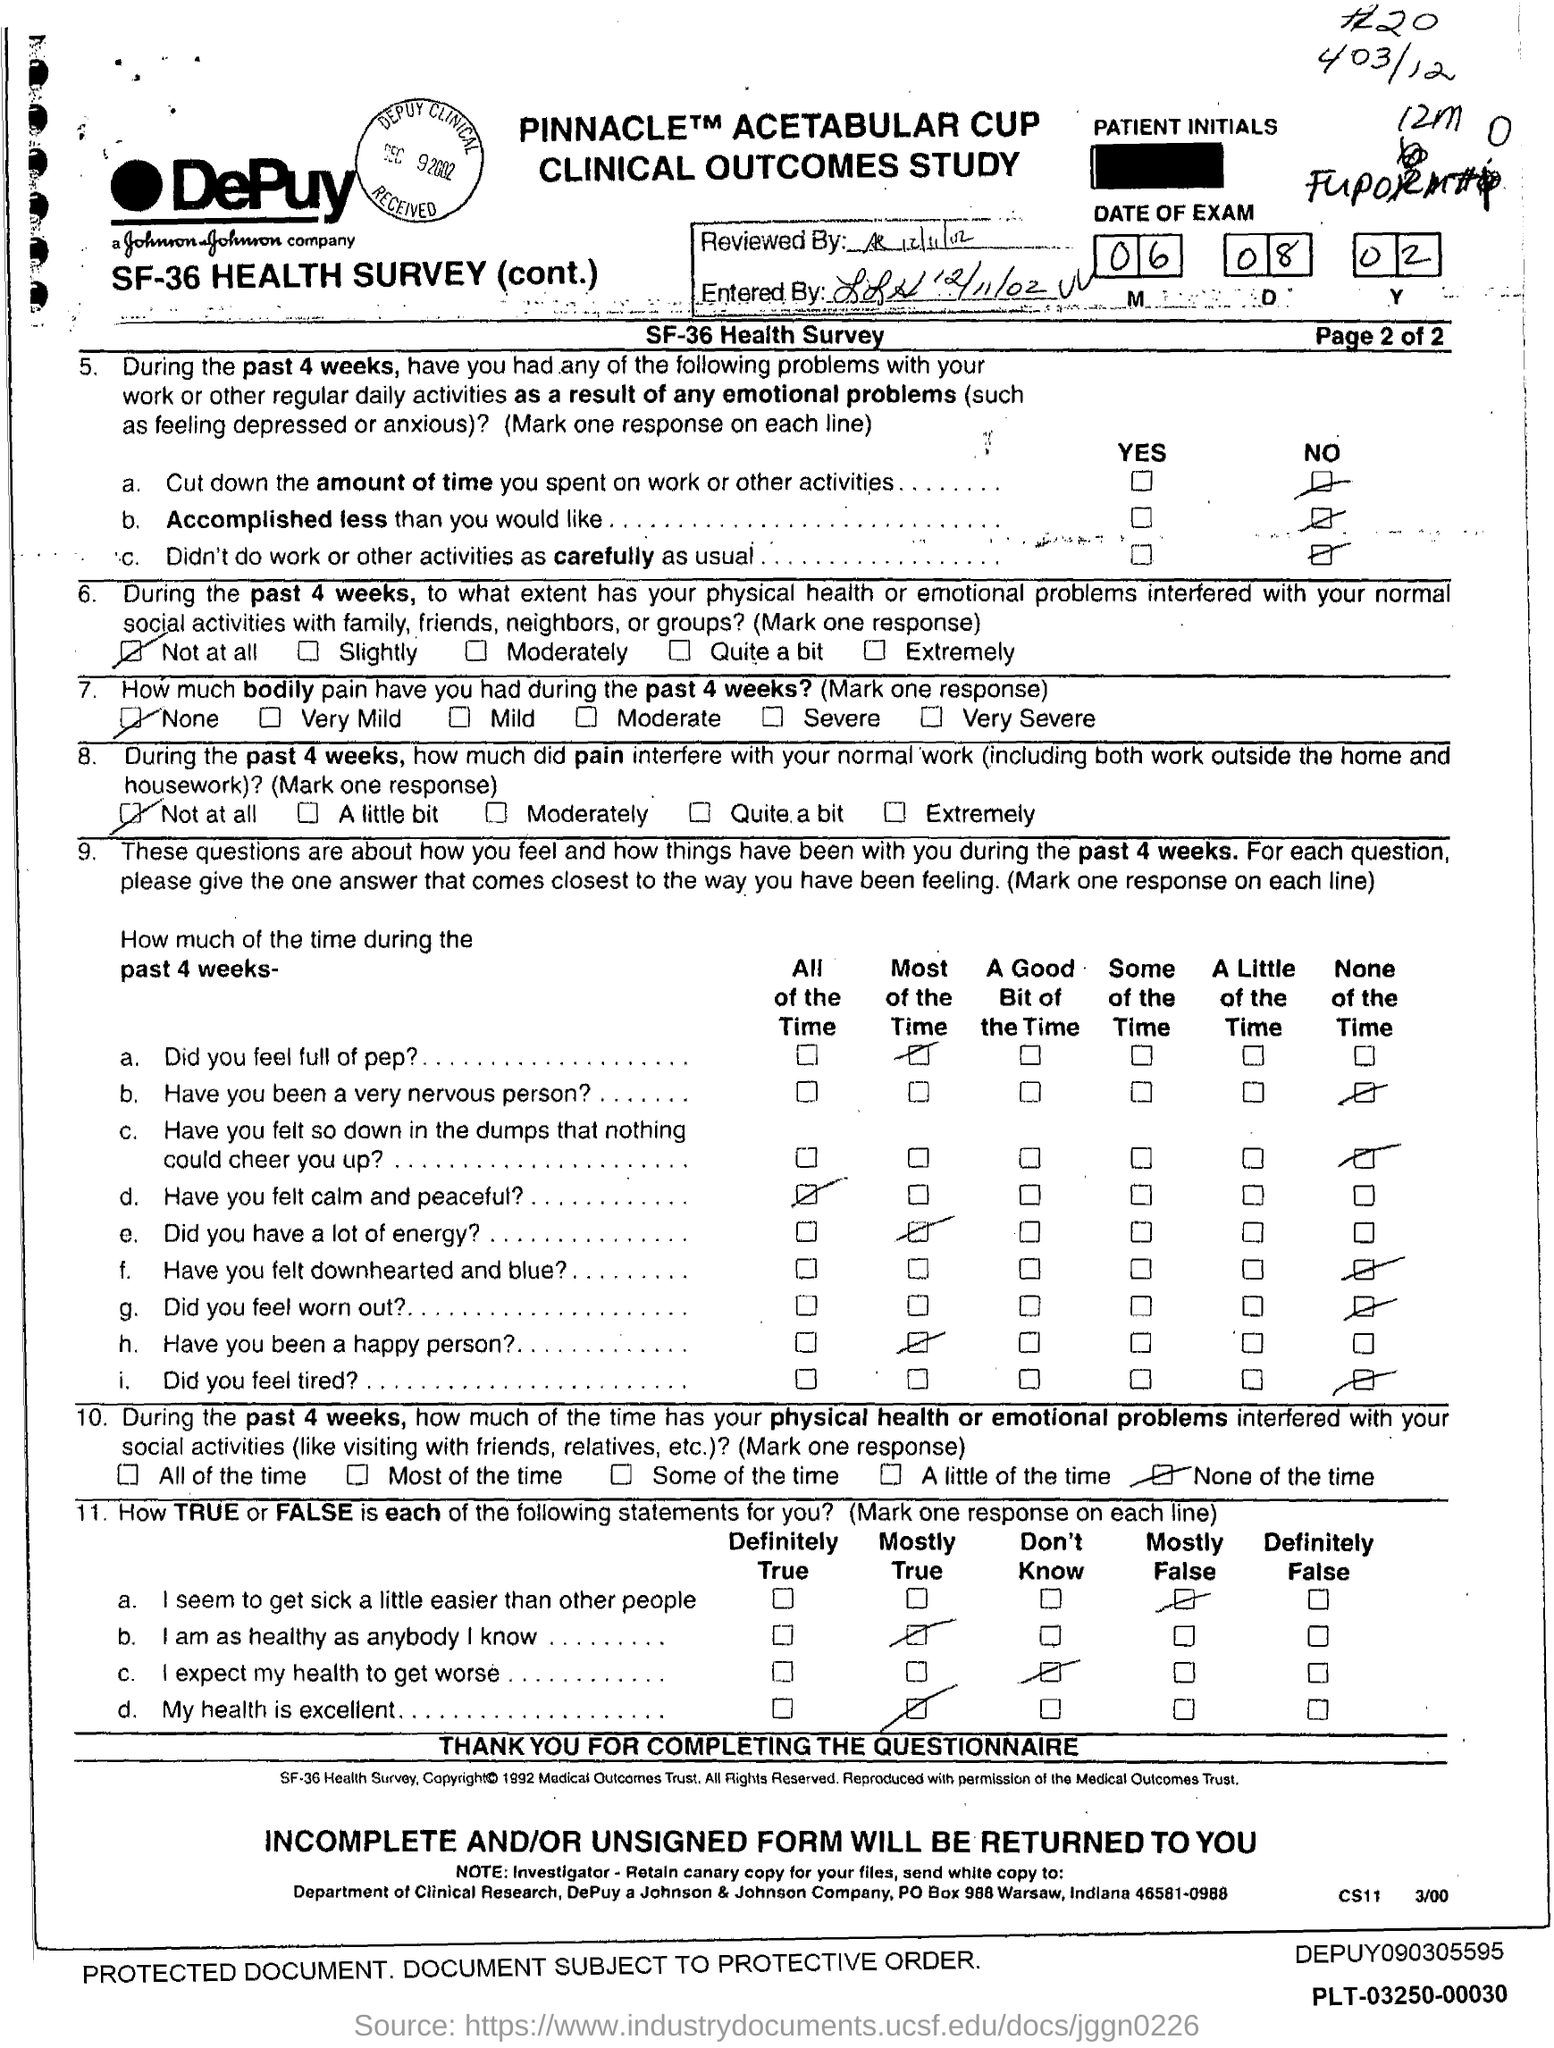List a handful of essential elements in this visual. The document indicates that the Reviewed date is 12/11/02. The entered date mentioned in the document is December 11, 2002. 